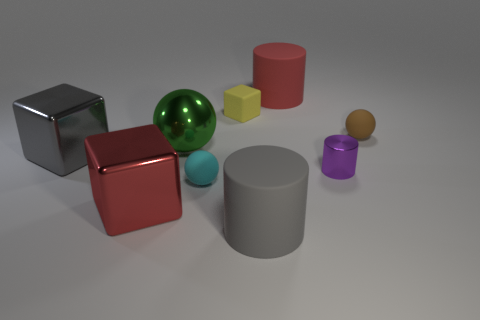Do the purple metal cylinder and the gray thing that is to the left of the large gray cylinder have the same size?
Ensure brevity in your answer.  No. Does the big block behind the large red metallic block have the same material as the tiny object behind the small brown rubber sphere?
Keep it short and to the point. No. Is the number of gray blocks that are to the left of the red metallic block the same as the number of large gray metallic objects behind the big gray metallic block?
Give a very brief answer. No. How many rubber things are big gray blocks or purple objects?
Offer a terse response. 0. Is the shape of the small yellow rubber thing behind the tiny purple metal cylinder the same as the big red thing to the left of the yellow rubber cube?
Ensure brevity in your answer.  Yes. What number of tiny purple cylinders are to the left of the yellow matte thing?
Provide a short and direct response. 0. Is there a red thing that has the same material as the gray block?
Offer a terse response. Yes. What material is the sphere that is the same size as the gray cylinder?
Your answer should be very brief. Metal. Is the material of the red block the same as the gray cylinder?
Provide a succinct answer. No. How many objects are green metal balls or red cylinders?
Ensure brevity in your answer.  2. 